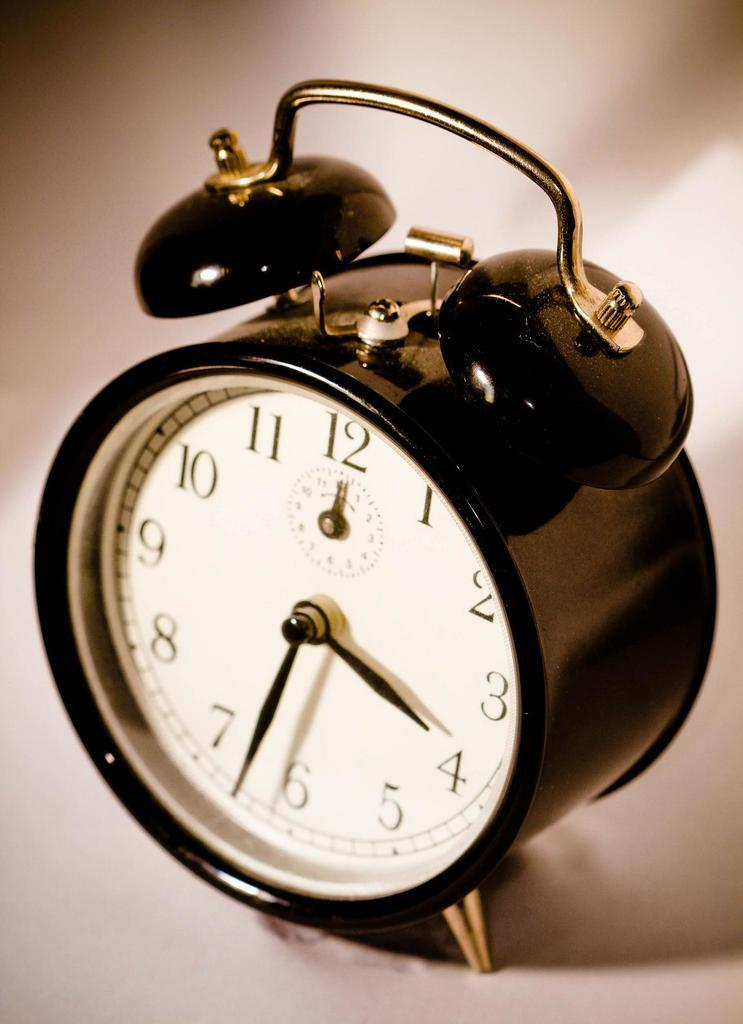<image>
Present a compact description of the photo's key features. An old fashion alarm clock showing that it is 3:33. 